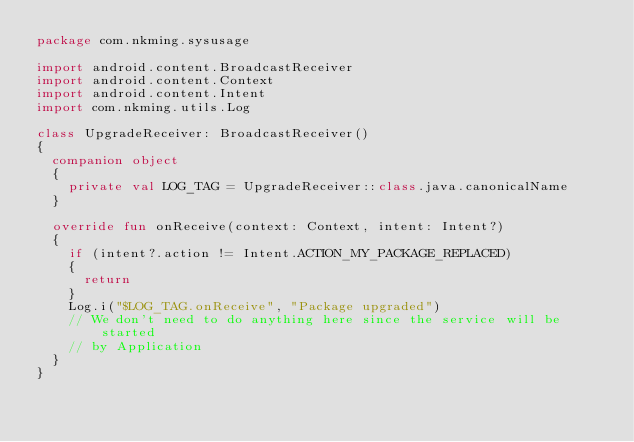<code> <loc_0><loc_0><loc_500><loc_500><_Kotlin_>package com.nkming.sysusage

import android.content.BroadcastReceiver
import android.content.Context
import android.content.Intent
import com.nkming.utils.Log

class UpgradeReceiver: BroadcastReceiver()
{
	companion object
	{
		private val LOG_TAG = UpgradeReceiver::class.java.canonicalName
	}

	override fun onReceive(context: Context, intent: Intent?)
	{
		if (intent?.action != Intent.ACTION_MY_PACKAGE_REPLACED)
		{
			return
		}
		Log.i("$LOG_TAG.onReceive", "Package upgraded")
		// We don't need to do anything here since the service will be started
		// by Application
	}
}
</code> 